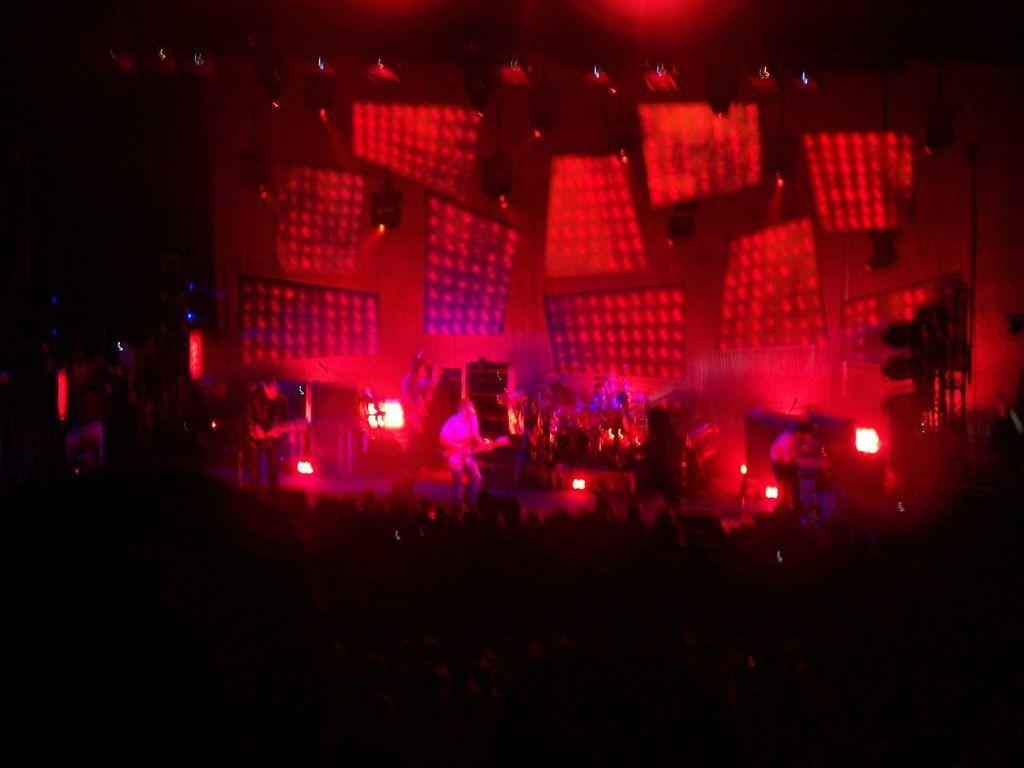What is happening on the stage in the image? There are people performing on a stage in the image. What can be seen on the stage besides the performers? There are lights on the stage. What type of skirt is the organization wearing in the image? There is no organization or skirt present in the image; it features people performing on a stage with lights. How many times does the roll occur in the image? There is no roll present in the image; it features people performing on a stage with lights. 